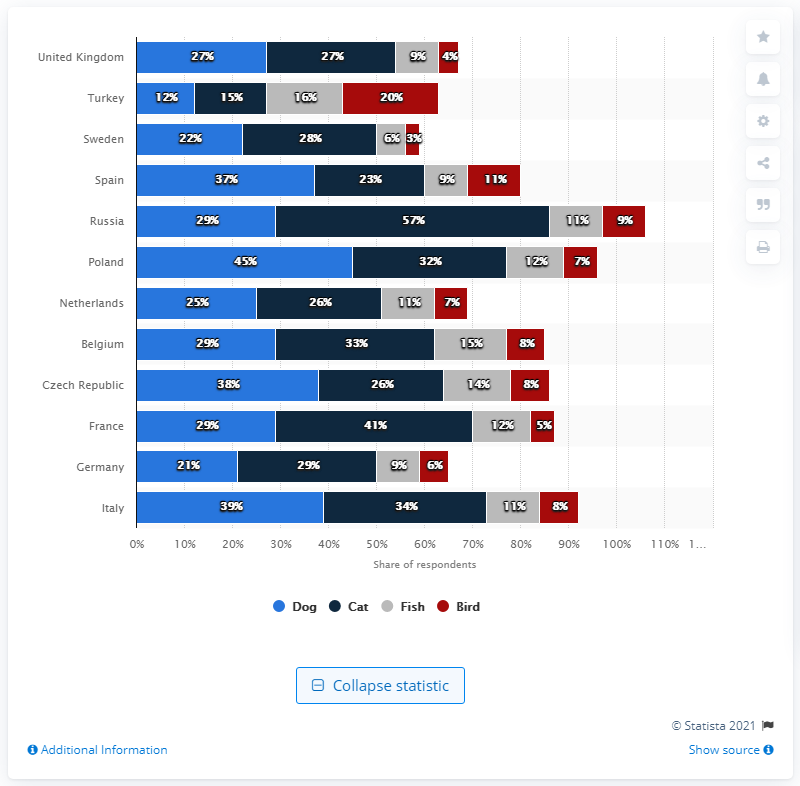Can we make any assumptions about the popularity of fish as pets in these countries? While fish ownership is not as high as cat or dog ownership in the countries shown, it's notable that the Netherlands has a relatively high percentage of fish owners at 10%. This might indicate a fondness for lower-maintenance pets or could be linked to the country's strong focus on interior design, where aquariums are a popular aesthetic choice. 